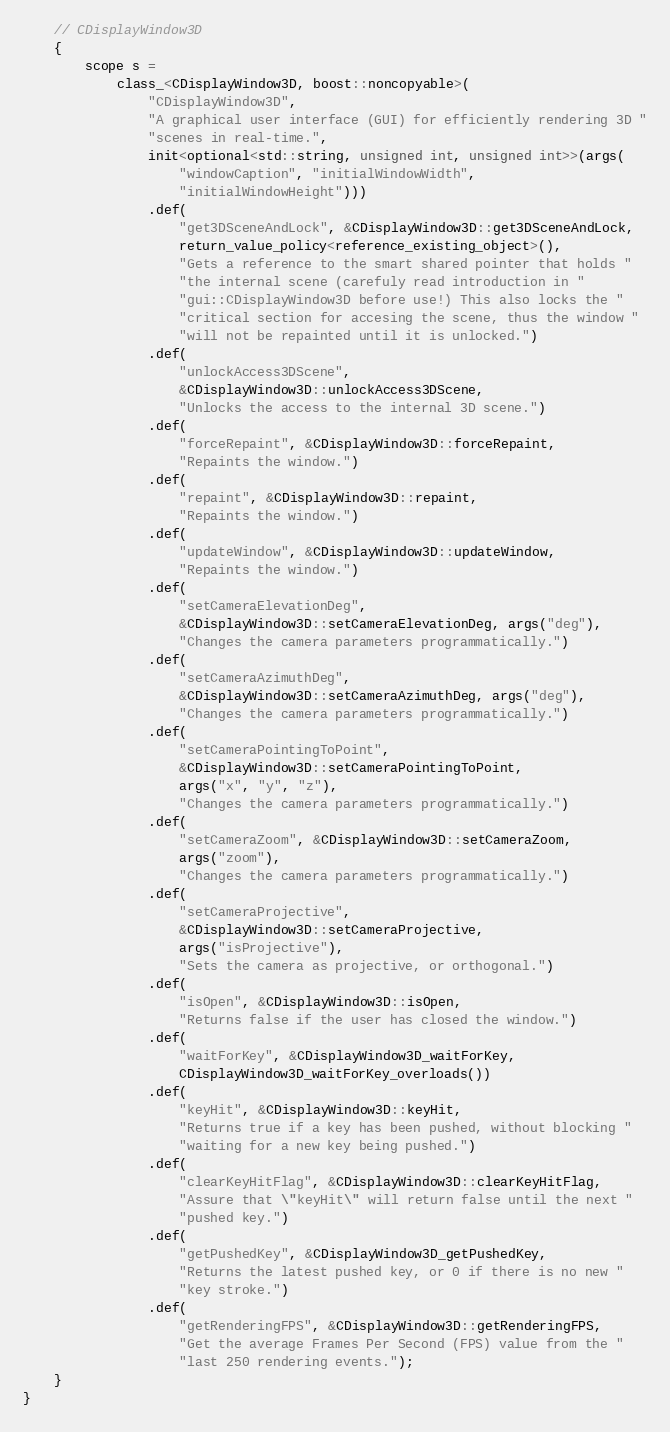Convert code to text. <code><loc_0><loc_0><loc_500><loc_500><_C++_>	// CDisplayWindow3D
	{
		scope s =
			class_<CDisplayWindow3D, boost::noncopyable>(
				"CDisplayWindow3D",
				"A graphical user interface (GUI) for efficiently rendering 3D "
				"scenes in real-time.",
				init<optional<std::string, unsigned int, unsigned int>>(args(
					"windowCaption", "initialWindowWidth",
					"initialWindowHeight")))
				.def(
					"get3DSceneAndLock", &CDisplayWindow3D::get3DSceneAndLock,
					return_value_policy<reference_existing_object>(),
					"Gets a reference to the smart shared pointer that holds "
					"the internal scene (carefuly read introduction in "
					"gui::CDisplayWindow3D before use!) This also locks the "
					"critical section for accesing the scene, thus the window "
					"will not be repainted until it is unlocked.")
				.def(
					"unlockAccess3DScene",
					&CDisplayWindow3D::unlockAccess3DScene,
					"Unlocks the access to the internal 3D scene.")
				.def(
					"forceRepaint", &CDisplayWindow3D::forceRepaint,
					"Repaints the window.")
				.def(
					"repaint", &CDisplayWindow3D::repaint,
					"Repaints the window.")
				.def(
					"updateWindow", &CDisplayWindow3D::updateWindow,
					"Repaints the window.")
				.def(
					"setCameraElevationDeg",
					&CDisplayWindow3D::setCameraElevationDeg, args("deg"),
					"Changes the camera parameters programmatically.")
				.def(
					"setCameraAzimuthDeg",
					&CDisplayWindow3D::setCameraAzimuthDeg, args("deg"),
					"Changes the camera parameters programmatically.")
				.def(
					"setCameraPointingToPoint",
					&CDisplayWindow3D::setCameraPointingToPoint,
					args("x", "y", "z"),
					"Changes the camera parameters programmatically.")
				.def(
					"setCameraZoom", &CDisplayWindow3D::setCameraZoom,
					args("zoom"),
					"Changes the camera parameters programmatically.")
				.def(
					"setCameraProjective",
					&CDisplayWindow3D::setCameraProjective,
					args("isProjective"),
					"Sets the camera as projective, or orthogonal.")
				.def(
					"isOpen", &CDisplayWindow3D::isOpen,
					"Returns false if the user has closed the window.")
				.def(
					"waitForKey", &CDisplayWindow3D_waitForKey,
					CDisplayWindow3D_waitForKey_overloads())
				.def(
					"keyHit", &CDisplayWindow3D::keyHit,
					"Returns true if a key has been pushed, without blocking "
					"waiting for a new key being pushed.")
				.def(
					"clearKeyHitFlag", &CDisplayWindow3D::clearKeyHitFlag,
					"Assure that \"keyHit\" will return false until the next "
					"pushed key.")
				.def(
					"getPushedKey", &CDisplayWindow3D_getPushedKey,
					"Returns the latest pushed key, or 0 if there is no new "
					"key stroke.")
				.def(
					"getRenderingFPS", &CDisplayWindow3D::getRenderingFPS,
					"Get the average Frames Per Second (FPS) value from the "
					"last 250 rendering events.");
	}
}
</code> 